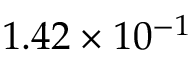<formula> <loc_0><loc_0><loc_500><loc_500>1 . 4 2 \times 1 0 ^ { - 1 }</formula> 